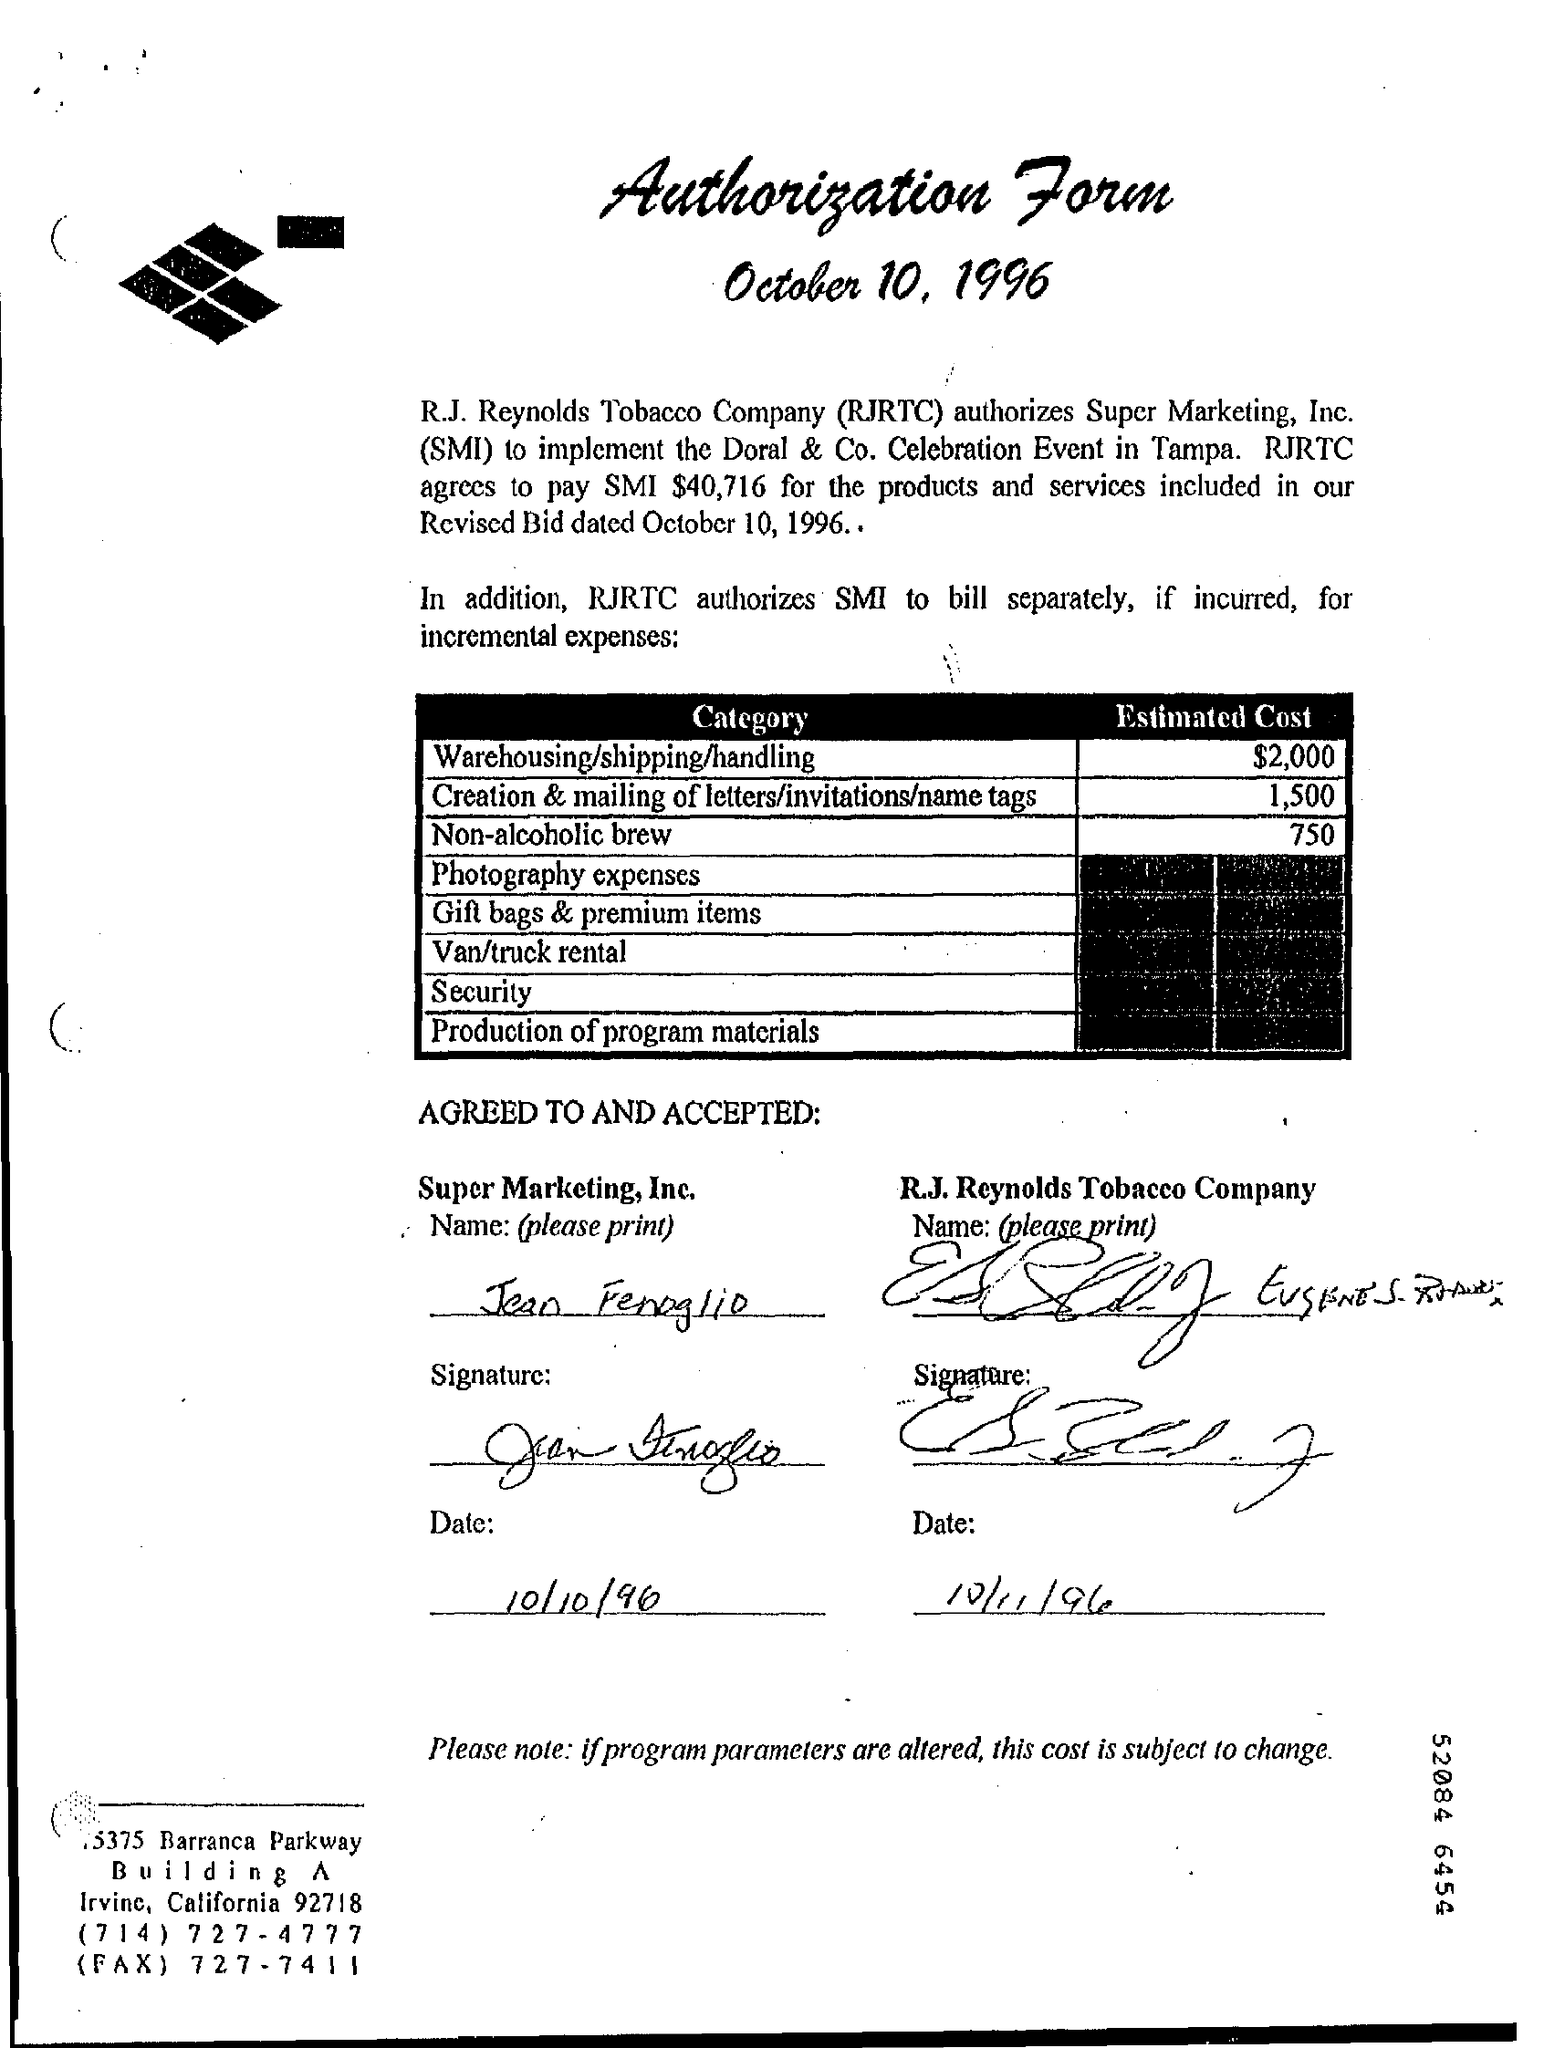Highlight a few significant elements in this photo. The date is October 10, 1996. The document is an authorization form. The estimated cost for the creation and mailing of letters, invitations, and name tags for the "Category" is 1,500. RJRTC has agreed to pay SMI a sum of $40,716. The estimated cost for a non-alcoholic brew in the 'Category' category is 750. 